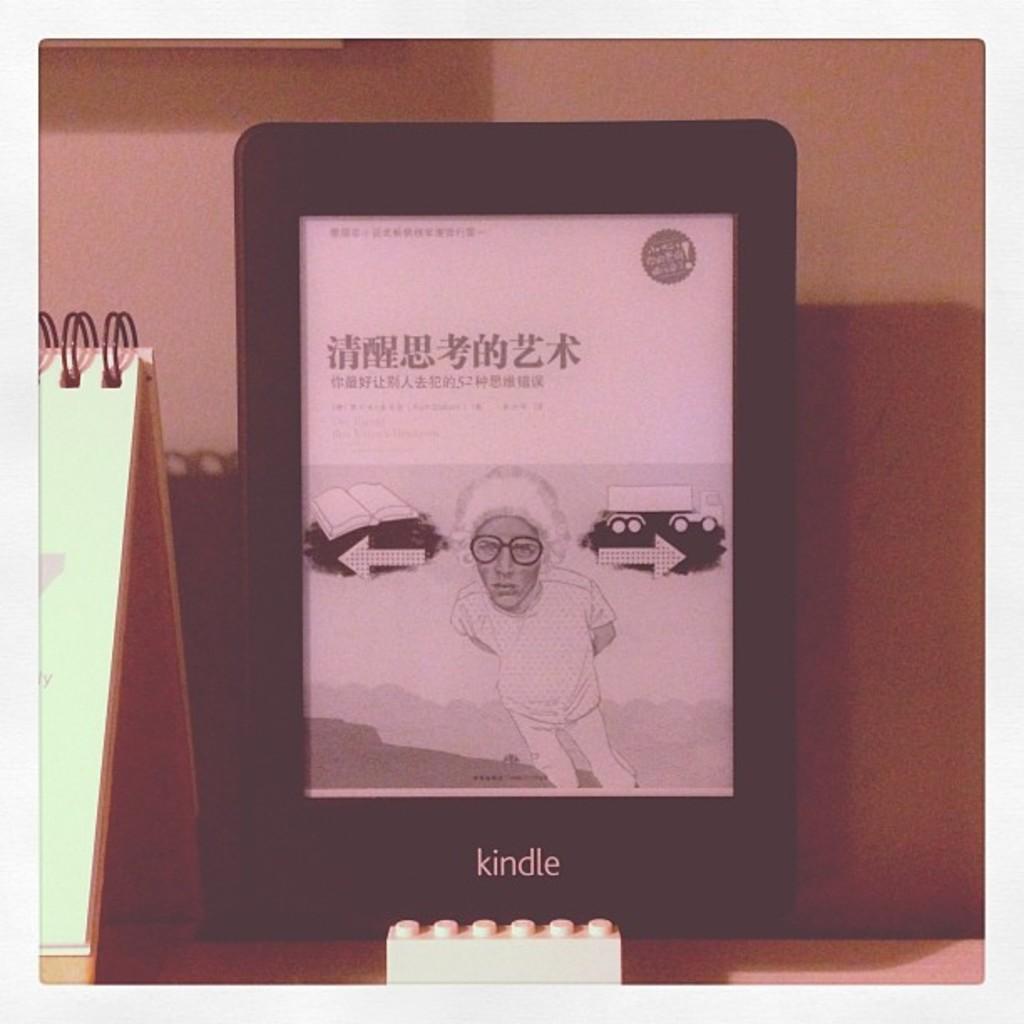Could you give a brief overview of what you see in this image? In this picture we can see a tab,on this tab we can see a person and in the background we can see a wall. 